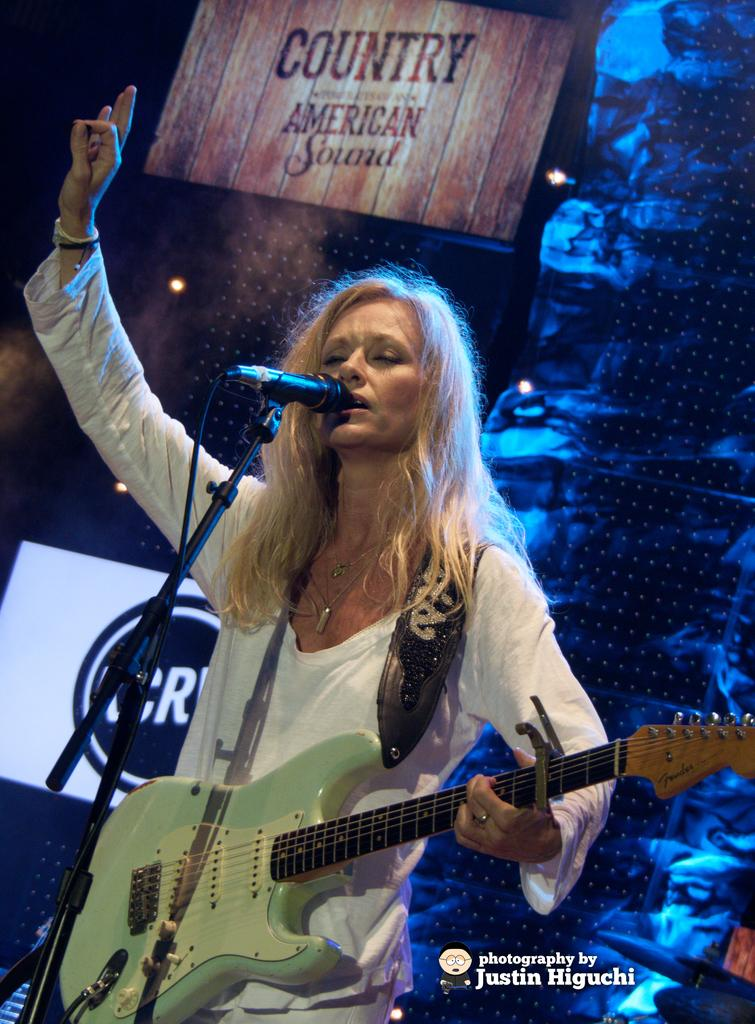What is the main subject of the image? There is a person in the image. What is the person wearing? The person is wearing a white T-shirt. What activity is the person engaged in? The person is playing a guitar. What object is in front of the person? There is a microphone in front of the person. What type of key is hanging from the person's neck in the image? There is no key visible in the image; the person is wearing a white T-shirt and playing a guitar. What sound do the bells make in the image? There are no bells present in the image; the person is playing a guitar and there is a microphone in front of them. 